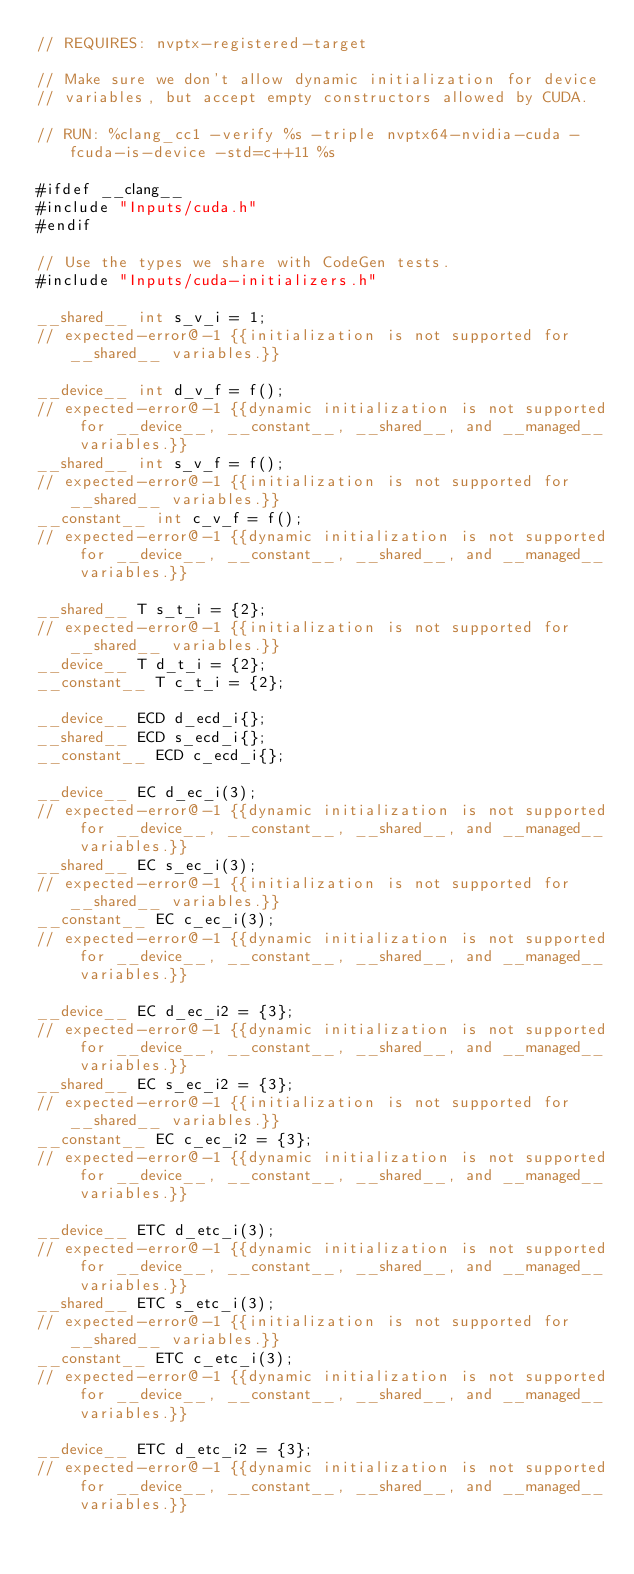Convert code to text. <code><loc_0><loc_0><loc_500><loc_500><_Cuda_>// REQUIRES: nvptx-registered-target

// Make sure we don't allow dynamic initialization for device
// variables, but accept empty constructors allowed by CUDA.

// RUN: %clang_cc1 -verify %s -triple nvptx64-nvidia-cuda -fcuda-is-device -std=c++11 %s

#ifdef __clang__
#include "Inputs/cuda.h"
#endif

// Use the types we share with CodeGen tests.
#include "Inputs/cuda-initializers.h"

__shared__ int s_v_i = 1;
// expected-error@-1 {{initialization is not supported for __shared__ variables.}}

__device__ int d_v_f = f();
// expected-error@-1 {{dynamic initialization is not supported for __device__, __constant__, __shared__, and __managed__ variables.}}
__shared__ int s_v_f = f();
// expected-error@-1 {{initialization is not supported for __shared__ variables.}}
__constant__ int c_v_f = f();
// expected-error@-1 {{dynamic initialization is not supported for __device__, __constant__, __shared__, and __managed__ variables.}}

__shared__ T s_t_i = {2};
// expected-error@-1 {{initialization is not supported for __shared__ variables.}}
__device__ T d_t_i = {2};
__constant__ T c_t_i = {2};

__device__ ECD d_ecd_i{};
__shared__ ECD s_ecd_i{};
__constant__ ECD c_ecd_i{};

__device__ EC d_ec_i(3);
// expected-error@-1 {{dynamic initialization is not supported for __device__, __constant__, __shared__, and __managed__ variables.}}
__shared__ EC s_ec_i(3);
// expected-error@-1 {{initialization is not supported for __shared__ variables.}}
__constant__ EC c_ec_i(3);
// expected-error@-1 {{dynamic initialization is not supported for __device__, __constant__, __shared__, and __managed__ variables.}}

__device__ EC d_ec_i2 = {3};
// expected-error@-1 {{dynamic initialization is not supported for __device__, __constant__, __shared__, and __managed__ variables.}}
__shared__ EC s_ec_i2 = {3};
// expected-error@-1 {{initialization is not supported for __shared__ variables.}}
__constant__ EC c_ec_i2 = {3};
// expected-error@-1 {{dynamic initialization is not supported for __device__, __constant__, __shared__, and __managed__ variables.}}

__device__ ETC d_etc_i(3);
// expected-error@-1 {{dynamic initialization is not supported for __device__, __constant__, __shared__, and __managed__ variables.}}
__shared__ ETC s_etc_i(3);
// expected-error@-1 {{initialization is not supported for __shared__ variables.}}
__constant__ ETC c_etc_i(3);
// expected-error@-1 {{dynamic initialization is not supported for __device__, __constant__, __shared__, and __managed__ variables.}}

__device__ ETC d_etc_i2 = {3};
// expected-error@-1 {{dynamic initialization is not supported for __device__, __constant__, __shared__, and __managed__ variables.}}</code> 